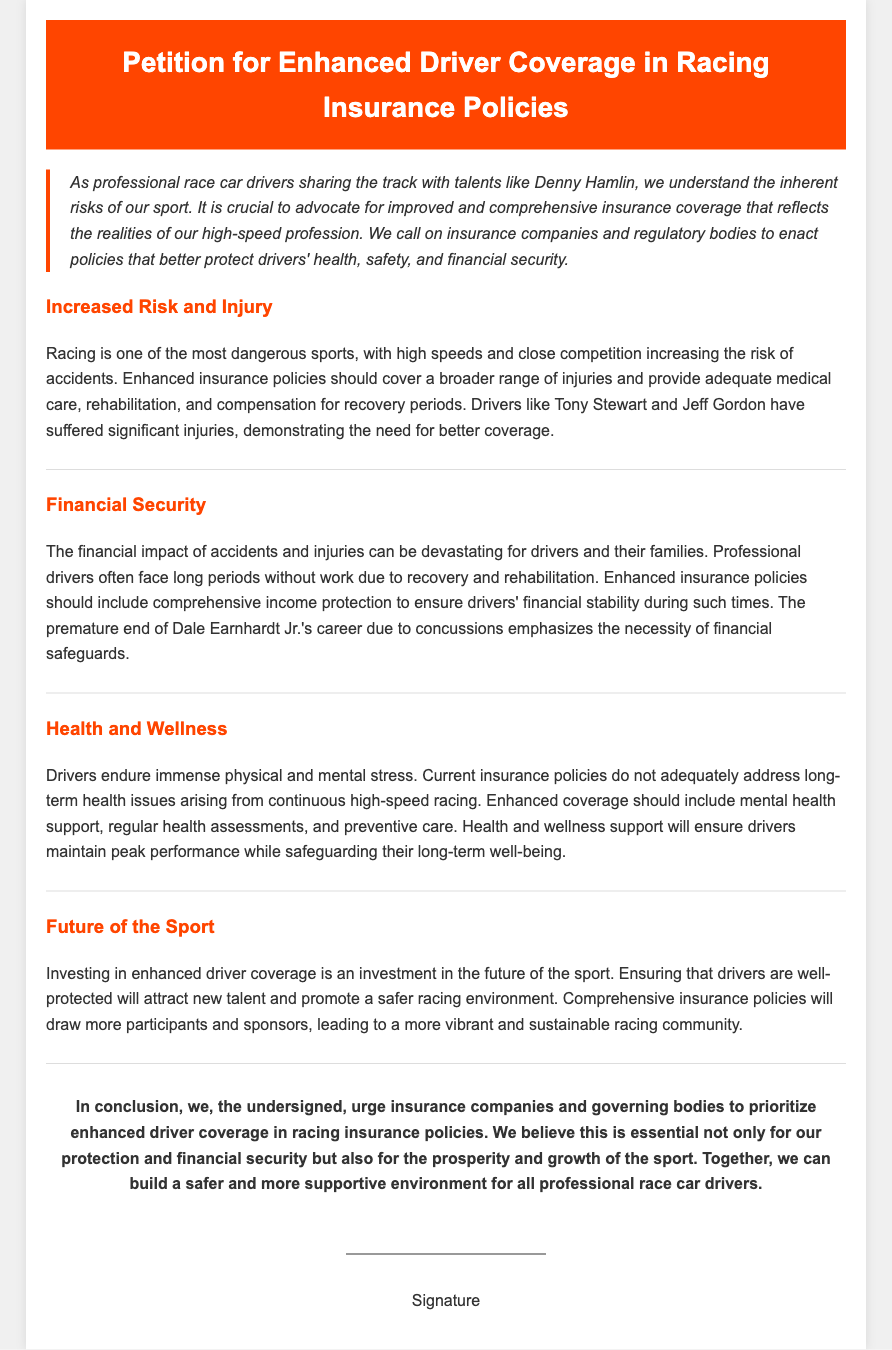What is the title of the petition? The title is clearly stated at the beginning of the document.
Answer: Petition for Enhanced Driver Coverage in Racing Insurance Policies Who are two drivers mentioned in the petition as examples? The document provides the names of specific drivers who faced significant injuries.
Answer: Tony Stewart and Jeff Gordon What should enhanced insurance policies cover according to the document? The petition outlines various aspects that enhanced insurance policies should address.
Answer: A broader range of injuries What is emphasized as necessary due to Dale Earnhardt Jr.'s career? The document references a particular aspect that underscores the need for improved policies.
Answer: Financial safeguards What is one of the proposed elements of enhanced coverage related to mental health? The argument includes a specific type of support that should be part of enhanced coverage.
Answer: Mental health support What two aspects does the conclusion urge insurance companies to prioritize? The conclusion summarizes the main points the petition advocates for.
Answer: Enhanced driver coverage How does the petition describe the future of the sport? The document discusses the potential benefits of improved insurance coverage for the sport's sustainability.
Answer: An investment in the future What color is used for the header background? The design of the document specifies the color used in the header section.
Answer: #ff4500 